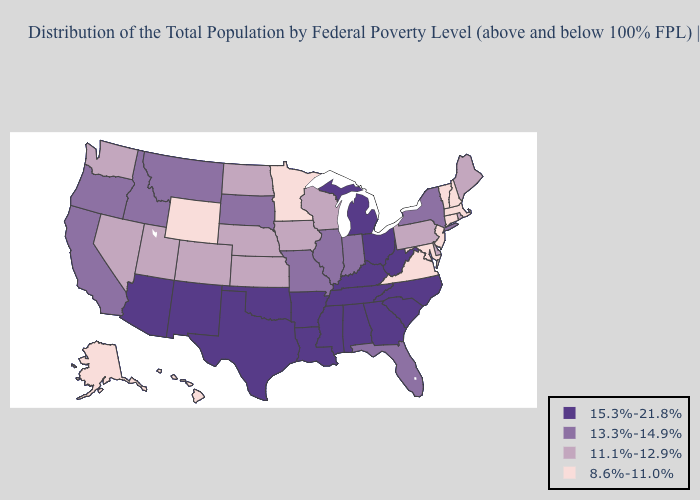Which states have the lowest value in the Northeast?
Give a very brief answer. Connecticut, Massachusetts, New Hampshire, New Jersey, Vermont. What is the value of Ohio?
Answer briefly. 15.3%-21.8%. Does the map have missing data?
Keep it brief. No. What is the lowest value in the Northeast?
Short answer required. 8.6%-11.0%. What is the highest value in the South ?
Concise answer only. 15.3%-21.8%. Name the states that have a value in the range 15.3%-21.8%?
Quick response, please. Alabama, Arizona, Arkansas, Georgia, Kentucky, Louisiana, Michigan, Mississippi, New Mexico, North Carolina, Ohio, Oklahoma, South Carolina, Tennessee, Texas, West Virginia. Does Oregon have a higher value than Minnesota?
Quick response, please. Yes. What is the value of Louisiana?
Give a very brief answer. 15.3%-21.8%. Name the states that have a value in the range 8.6%-11.0%?
Be succinct. Alaska, Connecticut, Hawaii, Maryland, Massachusetts, Minnesota, New Hampshire, New Jersey, Vermont, Virginia, Wyoming. Name the states that have a value in the range 8.6%-11.0%?
Give a very brief answer. Alaska, Connecticut, Hawaii, Maryland, Massachusetts, Minnesota, New Hampshire, New Jersey, Vermont, Virginia, Wyoming. Name the states that have a value in the range 8.6%-11.0%?
Keep it brief. Alaska, Connecticut, Hawaii, Maryland, Massachusetts, Minnesota, New Hampshire, New Jersey, Vermont, Virginia, Wyoming. How many symbols are there in the legend?
Keep it brief. 4. What is the value of Oregon?
Give a very brief answer. 13.3%-14.9%. Which states have the lowest value in the USA?
Be succinct. Alaska, Connecticut, Hawaii, Maryland, Massachusetts, Minnesota, New Hampshire, New Jersey, Vermont, Virginia, Wyoming. What is the lowest value in the West?
Keep it brief. 8.6%-11.0%. 